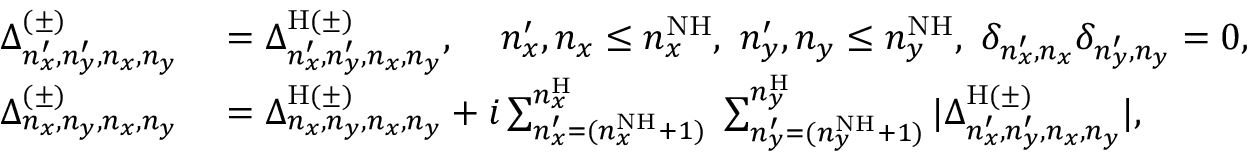Convert formula to latex. <formula><loc_0><loc_0><loc_500><loc_500>\begin{array} { r l } { \Delta _ { n _ { x } ^ { \prime } , n _ { y } ^ { \prime } , n _ { x } , n _ { y } } ^ { ( \pm ) } } & = \Delta _ { n _ { x } ^ { \prime } , n _ { y } ^ { \prime } , n _ { x } , n _ { y } } ^ { H ( \pm ) } , \, n _ { x } ^ { \prime } , n _ { x } \leq n _ { x } ^ { N H } , \, n _ { y } ^ { \prime } , n _ { y } \leq n _ { y } ^ { N H } , \, \delta _ { n _ { x } ^ { \prime } , n _ { x } } \delta _ { n _ { y } ^ { \prime } , n _ { y } } = 0 , } \\ { \Delta _ { n _ { x } , n _ { y } , n _ { x } , n _ { y } } ^ { ( \pm ) } } & = \Delta _ { n _ { x } , n _ { y } , n _ { x } , n _ { y } } ^ { H ( \pm ) } + i \sum _ { n _ { x } ^ { \prime } = ( n _ { x } ^ { N H } + 1 ) } ^ { n _ { x } ^ { H } } \, \sum _ { n _ { y } ^ { \prime } = ( n _ { y } ^ { N H } + 1 ) } ^ { n _ { y } ^ { H } } | \Delta _ { n _ { x } ^ { \prime } , n _ { y } ^ { \prime } , n _ { x } , n _ { y } } ^ { H ( \pm ) } | , } \end{array}</formula> 